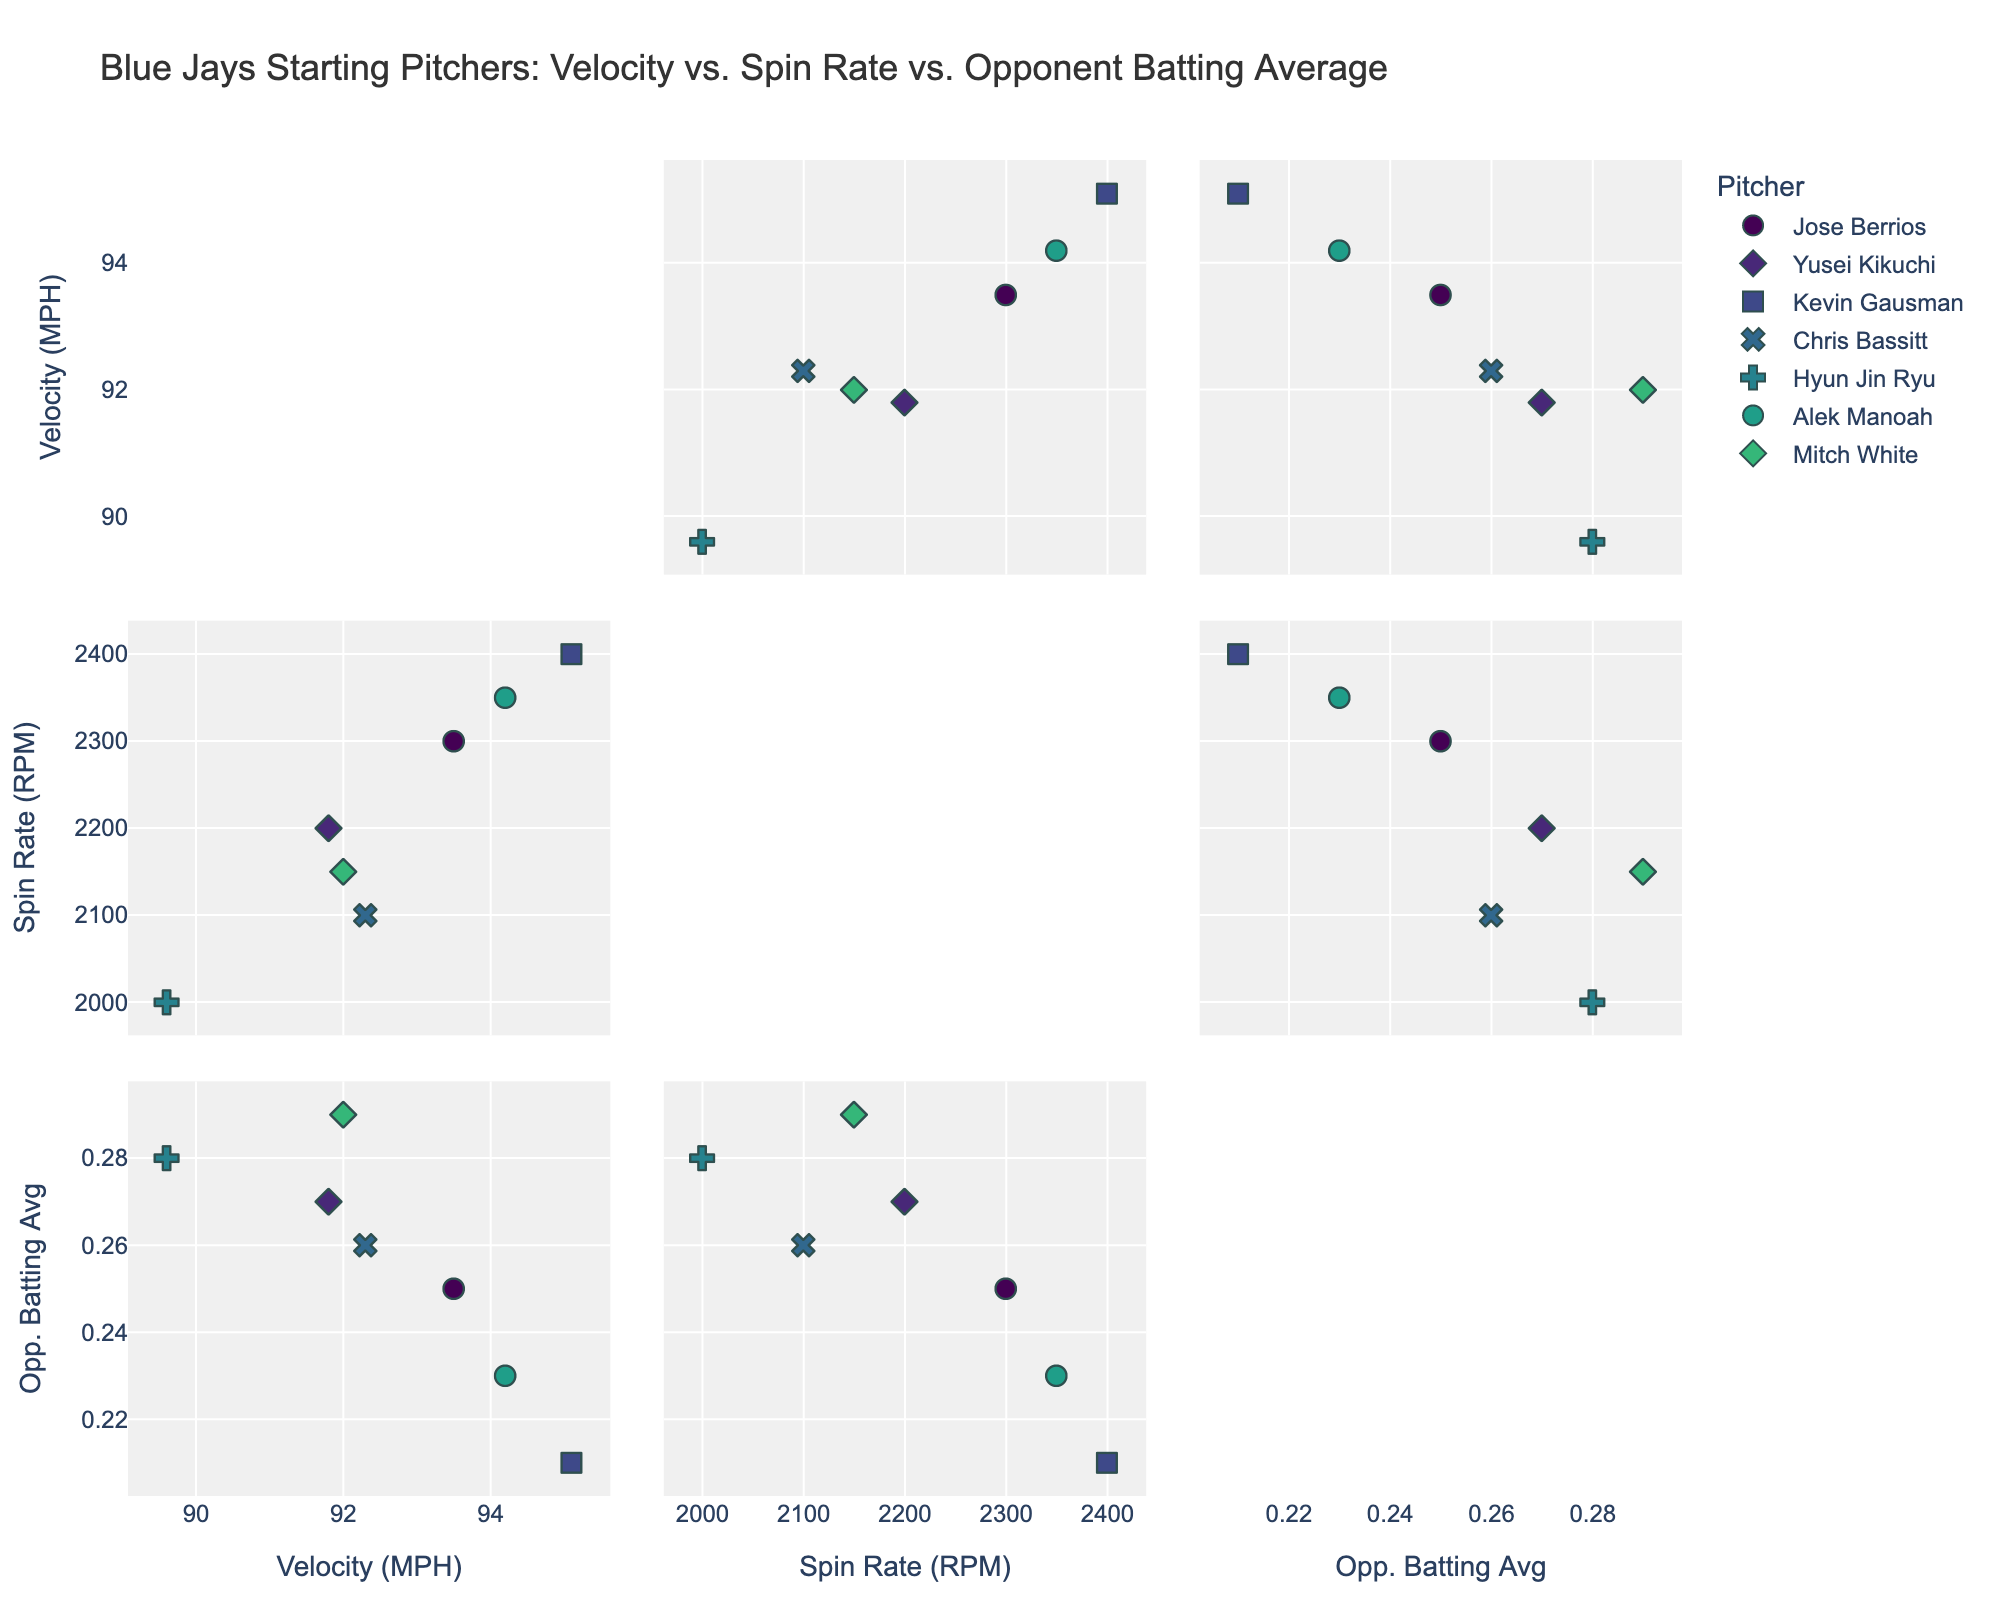What is the title of the plot? The title is visible at the top of the chart.
Answer: Blue Jays Starting Pitchers: Velocity vs. Spin Rate vs. Opponent Batting Average Which pitcher has the highest velocity? By looking at the scatter plot section of Velocity (MPH), we can identify the pitcher with the highest value.
Answer: Kevin Gausman How many pitchers have a spin rate above 2200 RPM? Refer to the Spin Rate (RPM) axis and count the data points above the 2200 RPM mark.
Answer: Four Which pitcher has the lowest opponent batting average? Checking the axis for Opponent Batting Average, identify the data point with the minimum value.
Answer: Kevin Gausman Is there a pitcher with high velocity and low opponent batting average? Locate data points that have a high coordinate on the Velocity (MPH) axis and a low coordinate on the Opponent Batting Average axis.
Answer: Yes, Kevin Gausman What is the range of velocities among the pitchers? Find the difference between the highest and lowest values on the Velocity (MPH) axis.
Answer: 5.5 MPH Do pitchers with higher spin rates generally have lower opponent batting averages? Look at the trends in the scatter plots comparing Spin Rate (RPM) and Opponent Batting Average.
Answer: Generally, yes Which two pitchers are closest in terms of both velocity and spin rate? Identify and compare the distances between data points in the scatter plots of Velocity (MPH) vs. Spin Rate (RPM).
Answer: Chris Bassitt and Mitch White Who has the highest spin rate with a batting average below 0.250? Filter data points by checking the highest values on Spin Rate (RPM) with respective Opponent Batting Average below 0.250.
Answer: Alek Manoah Which pitcher has the greatest disparity between spin rate and velocity? Calculate the absolute differences between Spin Rate (RPM) and Velocity (MPH) for each pitcher, then compare.
Answer: Hyun Jin Ryu 